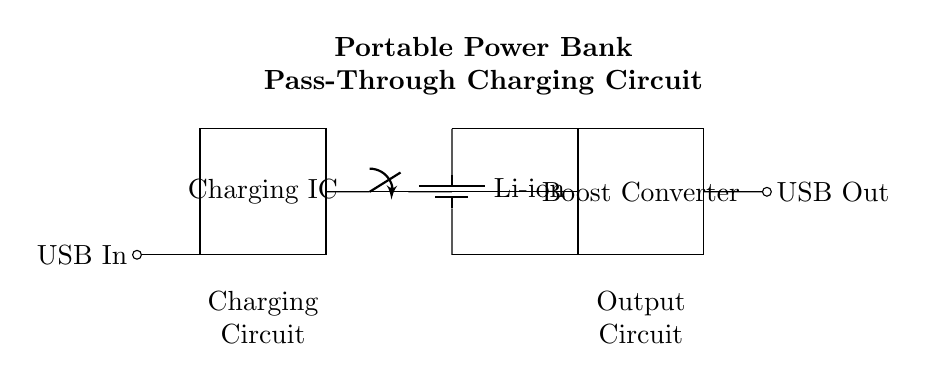What is the input type for charging? The circuit diagram indicates a USB input, shown by the labeled connection at the left side of the diagram.
Answer: USB What type of battery is used? The battery type is specified as a lithium-ion battery, indicated by the label next to the battery symbol.
Answer: Li-ion What component is responsible for increasing the output voltage? The boost converter is the component designed to increase the voltage output, as denoted by its label in the diagram.
Answer: Boost Converter What is the main function of the charging IC? The charging IC manages the charging of the battery and ensures safe operation, as it is labeled and positioned between the USB input and the battery.
Answer: Charging How does the system operate when you are charging and outputting simultaneously? The pass-through switch connects the charging IC directly to the boost converter, allowing currents from both the input and battery to flow to the output, highlighting the circuit's pass-through capability.
Answer: Pass-through What is the purpose of the switch in this circuit? The switch allows for control of the connection between the charging IC and the battery, making it essential for enabling or disabling the pass-through functionality.
Answer: Control connection 